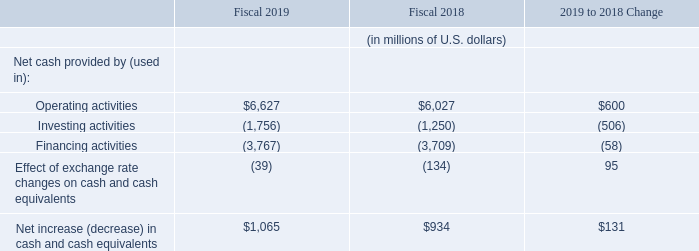Liquidity and Capital Resources
Our primary sources of liquidity are cash flows from operations, available cash reserves and debt capacity available under various credit facilities. We could raise additional funds through other public or private debt or equity financings. We may use our available or additional funds to, among other things
facilitate purchases, redemptions and exchanges of shares and pay dividends;
acquire complementary businesses or technologies;
take advantage of opportunities, including more rapid expansion; or
develop new services and solutions.
As of August 31, 2019, Cash and cash equivalents were $6.1 billion, compared with $5.1 billion as of August 31, 2018.
Cash flows from operating, investing and financing activities, as reflected in our Consolidated Cash Flows Statements, are summarized in the following table:
Operating activities: The $600 million year-over-year increase in operating cash flow was due to higher net income as well as changes in operating assets and liabilities, including an increase in accounts payable, partially offset by higher tax disbursements.
Investing activities: The $506 million increase in cash used was primarily due to higher spending on business acquisitions and investments. For additional information, see Note 6 (Business Combinations) to our Consolidated Financial Statements under Item 8, “Financial Statements and Supplementary Data.”
Financing activities: The $58 million increase in cash used was primarily due to an increase in cash dividends paid as well as an increase in purchases of shares, partially offset by an increase in proceeds from share issuances and a decrease in the purchase of additional interests in consolidated subsidiaries. For additional information, see Note 14 (Material Transactions Affecting Shareholders’ Equity) to our Consolidated Financial Statements under Item 8, “Financial Statements and Supplementary Data.”
We believe that our current and longer-term working capital, investments and other general corporate funding requirements will be satisfied for the next twelve months and thereafter through cash flows from operations and, to the extent necessary, from our borrowing facilities and future financial market activities
Substantially all of our cash is held in jurisdictions where there are no regulatory restrictions or material tax effects on the free flow of funds. In addition, domestic cash inflows for our Irish parent, principally dividend distributions from lower-tier subsidiaries, have been sufficient to meet our historic cash requirements, and we expect this to continue into the future.
What is the company's increase in income from operating activities between 2018 and 2019? 
Answer scale should be: million. $600. What is the company's cash and cash equivalents as at 31 August 2019? As of august 31, 2019, cash and cash equivalents were $6.1 billion. What is the increase in cash flow from investing activities between 2018 and 2019?
Answer scale should be: million. $506. What is the total cash flow in operating activity  in 2018 and 2019? $6,627 + $6,027 
Answer: 12654. What is the total cashflow from investing activities in both 2018 and 2019?
Answer scale should be: million. - 1,756 + (-1,250) 
Answer: -3006. What is the total effect of exchange rate changes on cash and cash equivalents in both 2018 and 2019?
Answer scale should be: million. -39+(-134) 
Answer: -173. 